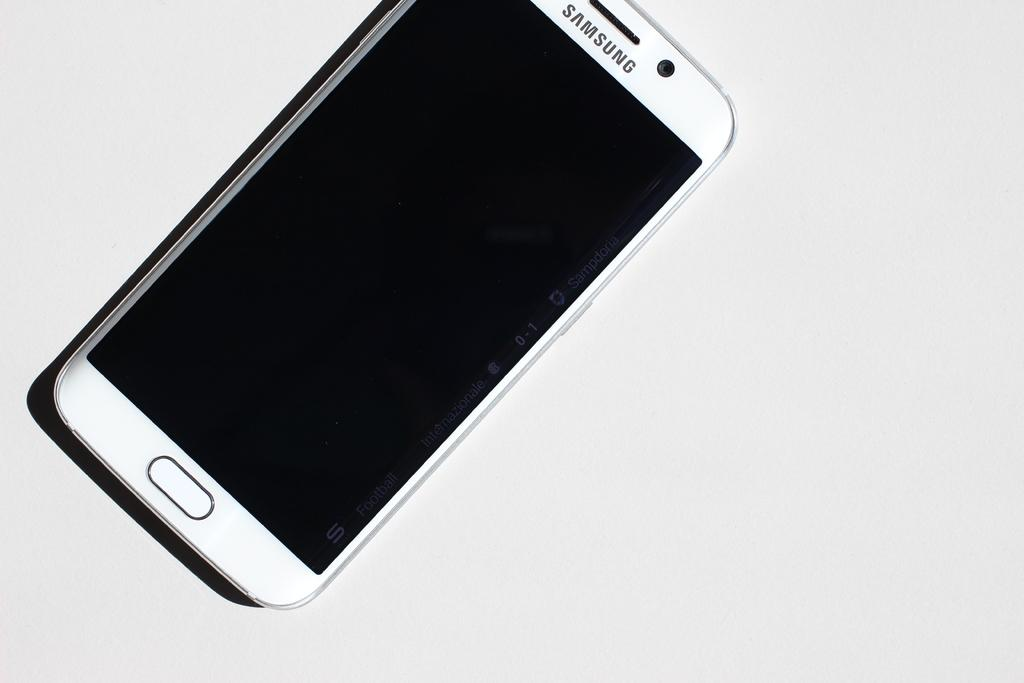<image>
Share a concise interpretation of the image provided. A Samsung smart phone is powered off and laying sideways. 